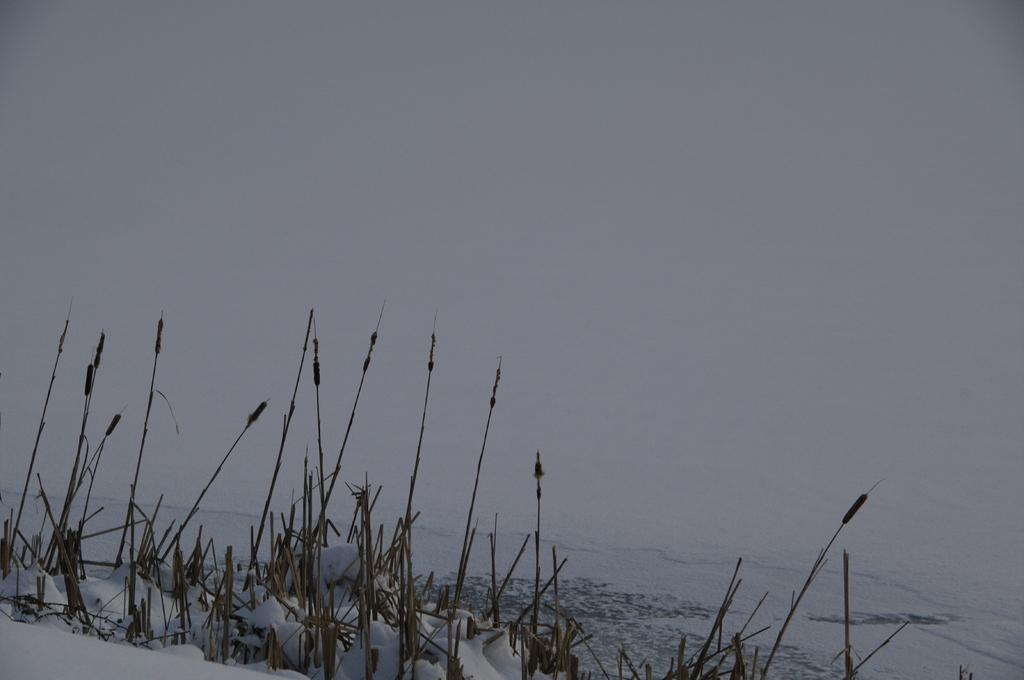What type of weather condition is depicted at the bottom of the image? There is snow at the bottom of the image. What else can be seen in the snow? There are plants in the snow. What color dominates the background of the image? The background of the image is white. What is the name of the baseball player featured in the image? There is no baseball player or any reference to baseball in the image. 